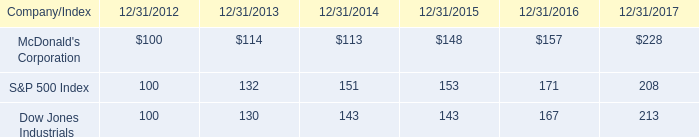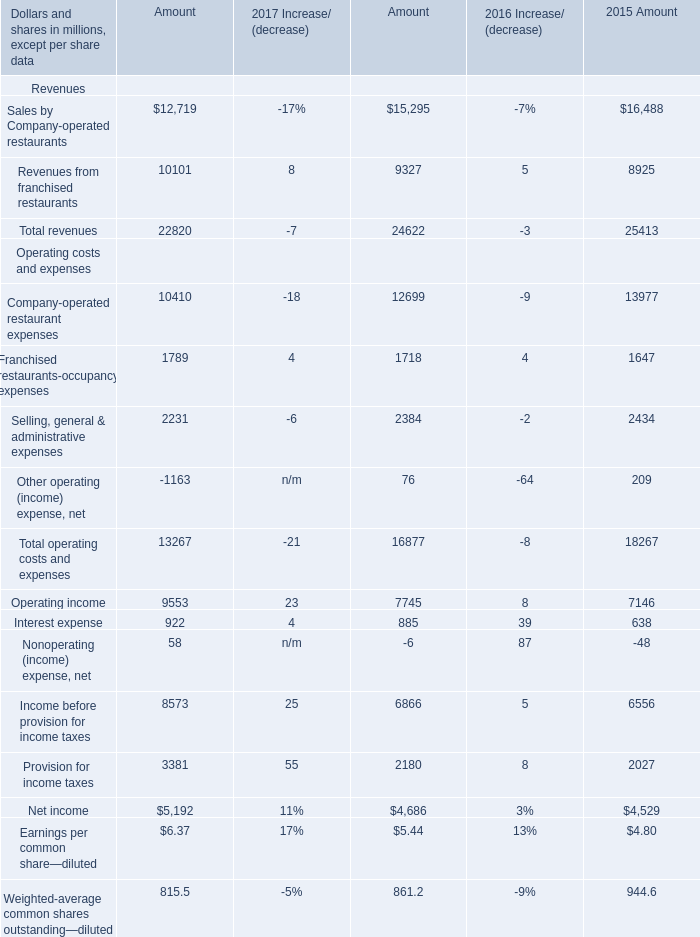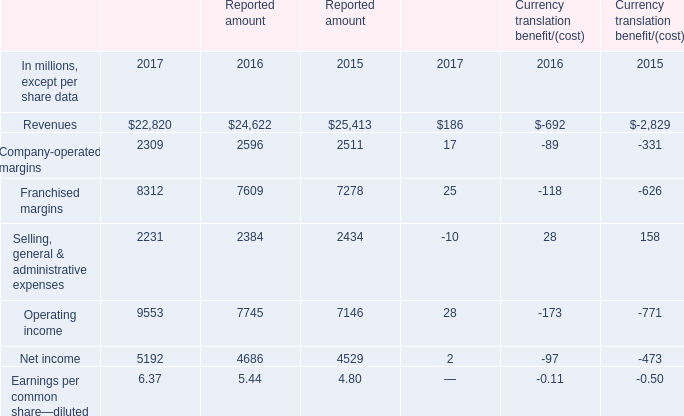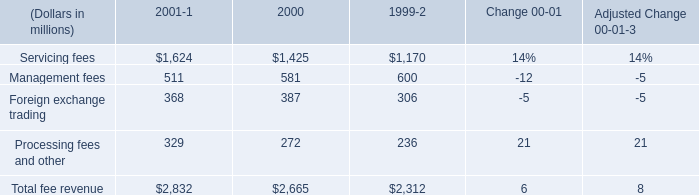what is the growth rate in total fee revenue in 2001? 
Computations: ((2832 - 2665) / 2665)
Answer: 0.06266. 